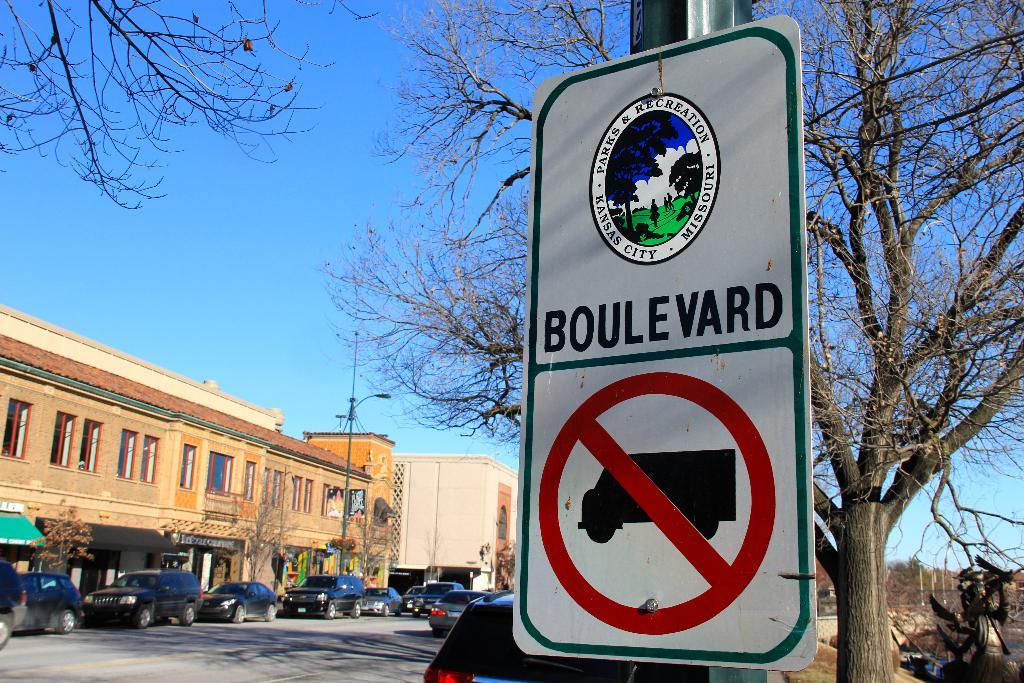What is the sign showing?
Offer a terse response. Boulevard. What are the state names on the top of the sign surrounding the logo?
Offer a very short reply. Missouri. 